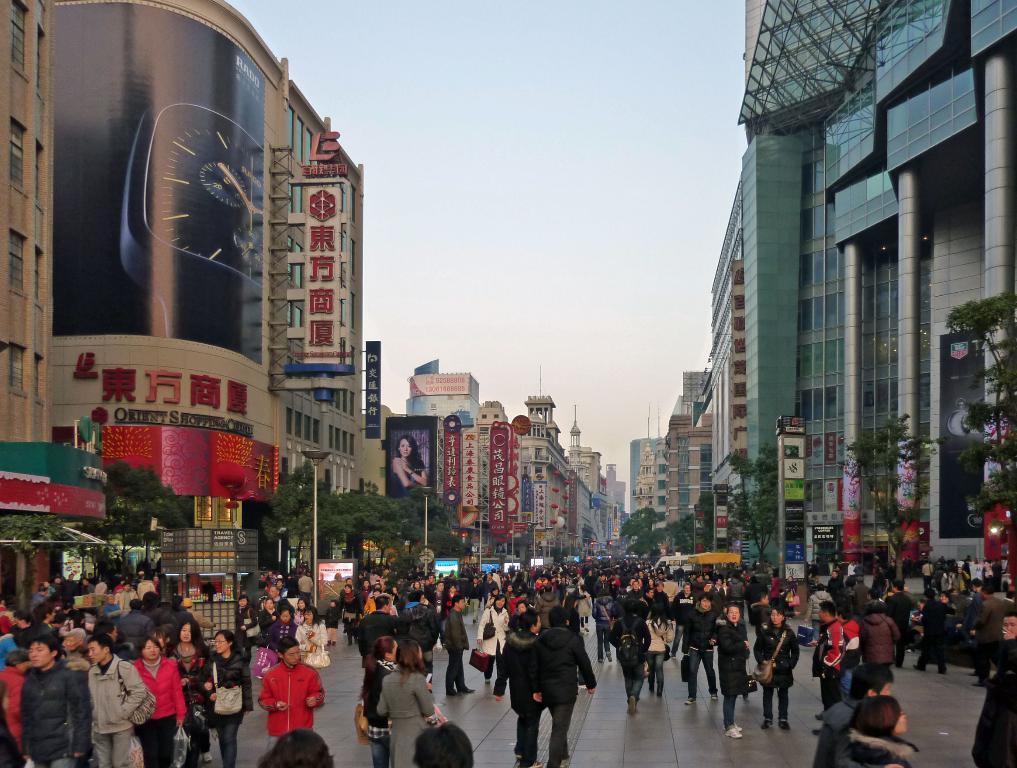Could you give a brief overview of what you see in this image? In this image we can see many people and few people are carrying some objects in their hands. There are many buildings in the image. There are many advertising boards in the image. We can see the sky in the image. There are many trees in the image. 